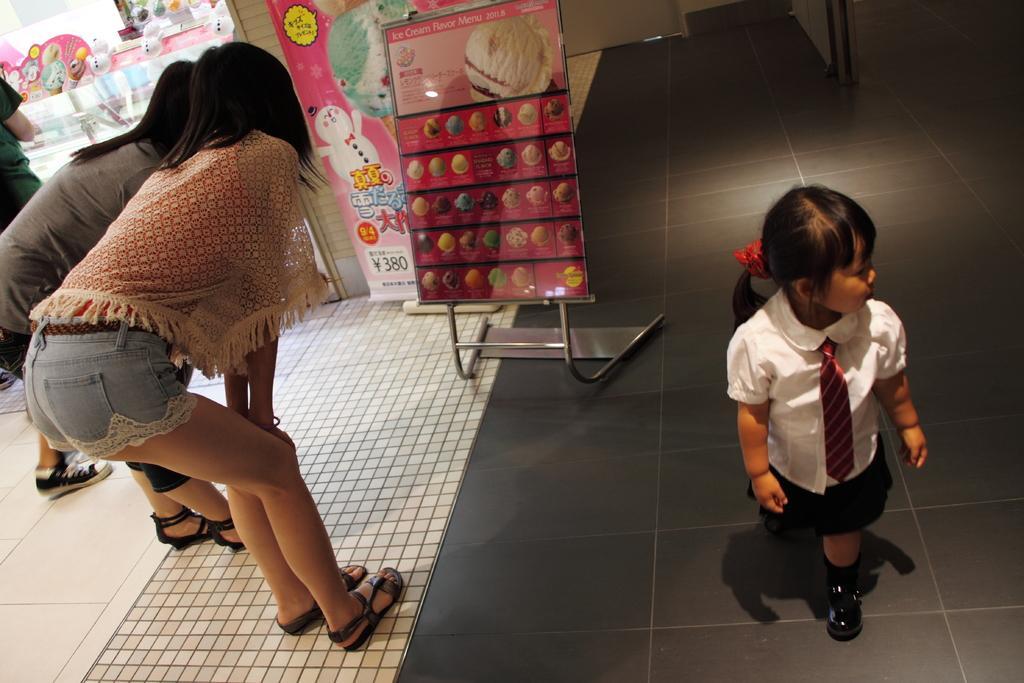In one or two sentences, can you explain what this image depicts? In this image there is a small girl walking on the floor, beside that there are two girls standing and looking at the poster, also there is another girl standing near the shop. 